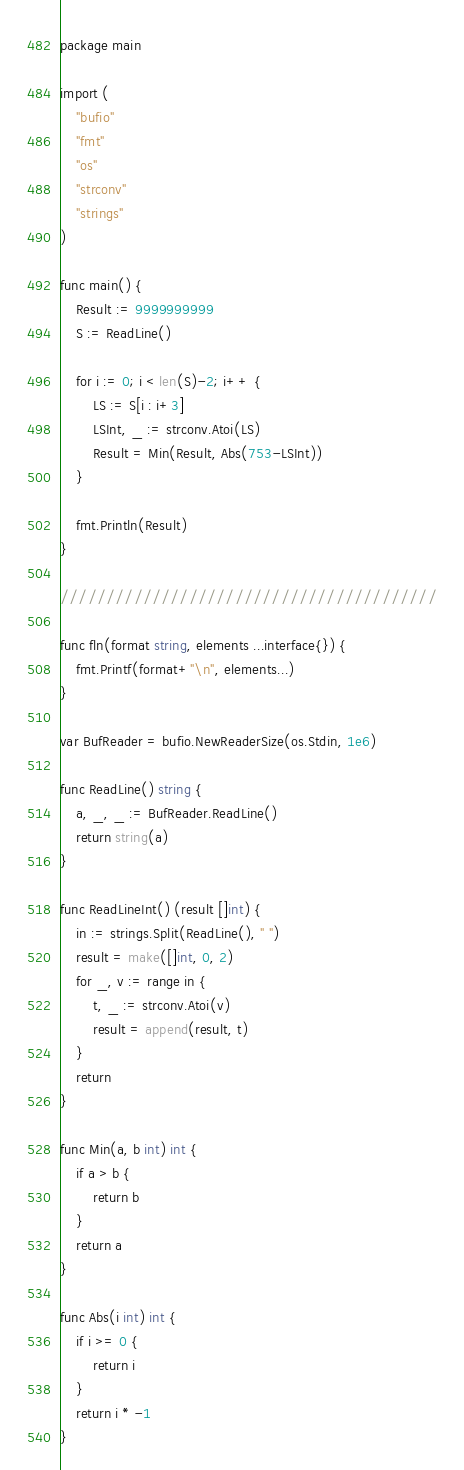Convert code to text. <code><loc_0><loc_0><loc_500><loc_500><_Go_>package main

import (
	"bufio"
	"fmt"
	"os"
	"strconv"
	"strings"
)

func main() {
	Result := 9999999999
	S := ReadLine()

	for i := 0; i < len(S)-2; i++ {
		LS := S[i : i+3]
		LSInt, _ := strconv.Atoi(LS)
		Result = Min(Result, Abs(753-LSInt))
	}

	fmt.Println(Result)
}

/////////////////////////////////////////

func fln(format string, elements ...interface{}) {
	fmt.Printf(format+"\n", elements...)
}

var BufReader = bufio.NewReaderSize(os.Stdin, 1e6)

func ReadLine() string {
	a, _, _ := BufReader.ReadLine()
	return string(a)
}

func ReadLineInt() (result []int) {
	in := strings.Split(ReadLine(), " ")
	result = make([]int, 0, 2)
	for _, v := range in {
		t, _ := strconv.Atoi(v)
		result = append(result, t)
	}
	return
}

func Min(a, b int) int {
	if a > b {
		return b
	}
	return a
}

func Abs(i int) int {
	if i >= 0 {
		return i
	}
	return i * -1
}
</code> 